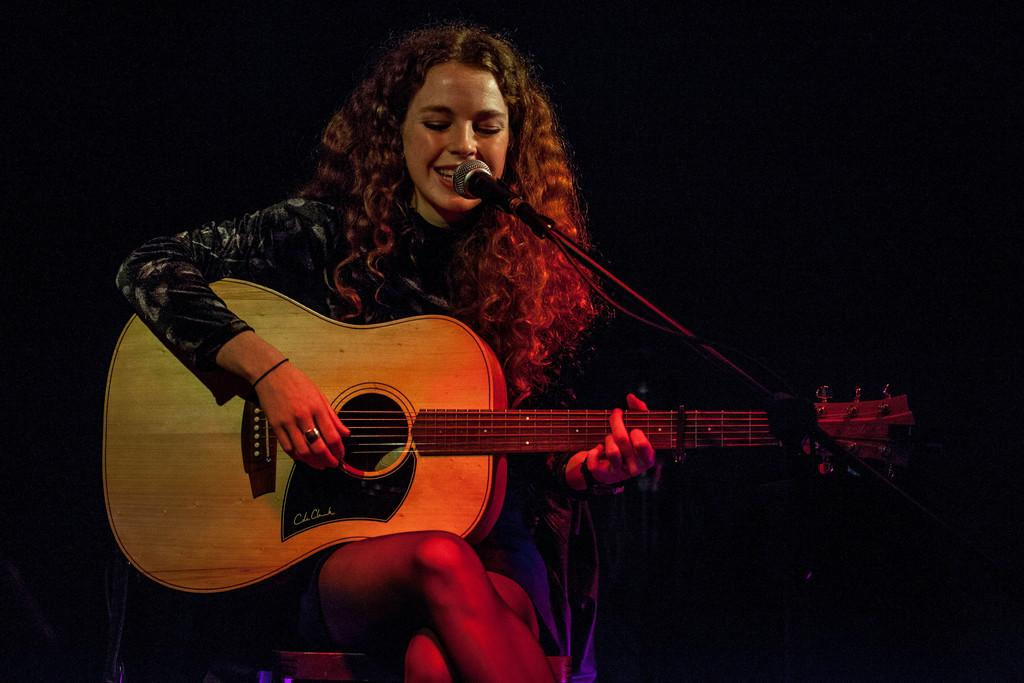Who is the main subject in the image? There is a woman in the image. What is the woman doing in the image? The woman is sitting on a chair, playing a guitar, and singing. What object is in front of the woman? There is a microphone in front of the woman. What type of oil is being used to paint the woman in the image? There is no painting or oil present in the image; it features a woman playing a guitar and singing. 